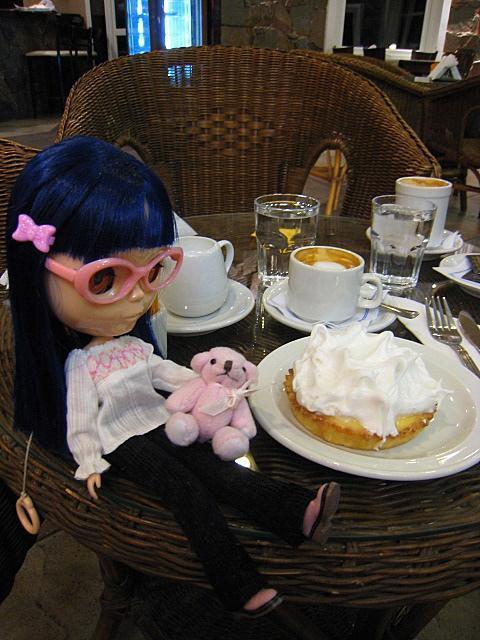Does the image validate the caption "The dining table is at the right side of the teddy bear."?
Answer yes or no. No. Is the given caption "The dining table is under the teddy bear." fitting for the image?
Answer yes or no. Yes. 